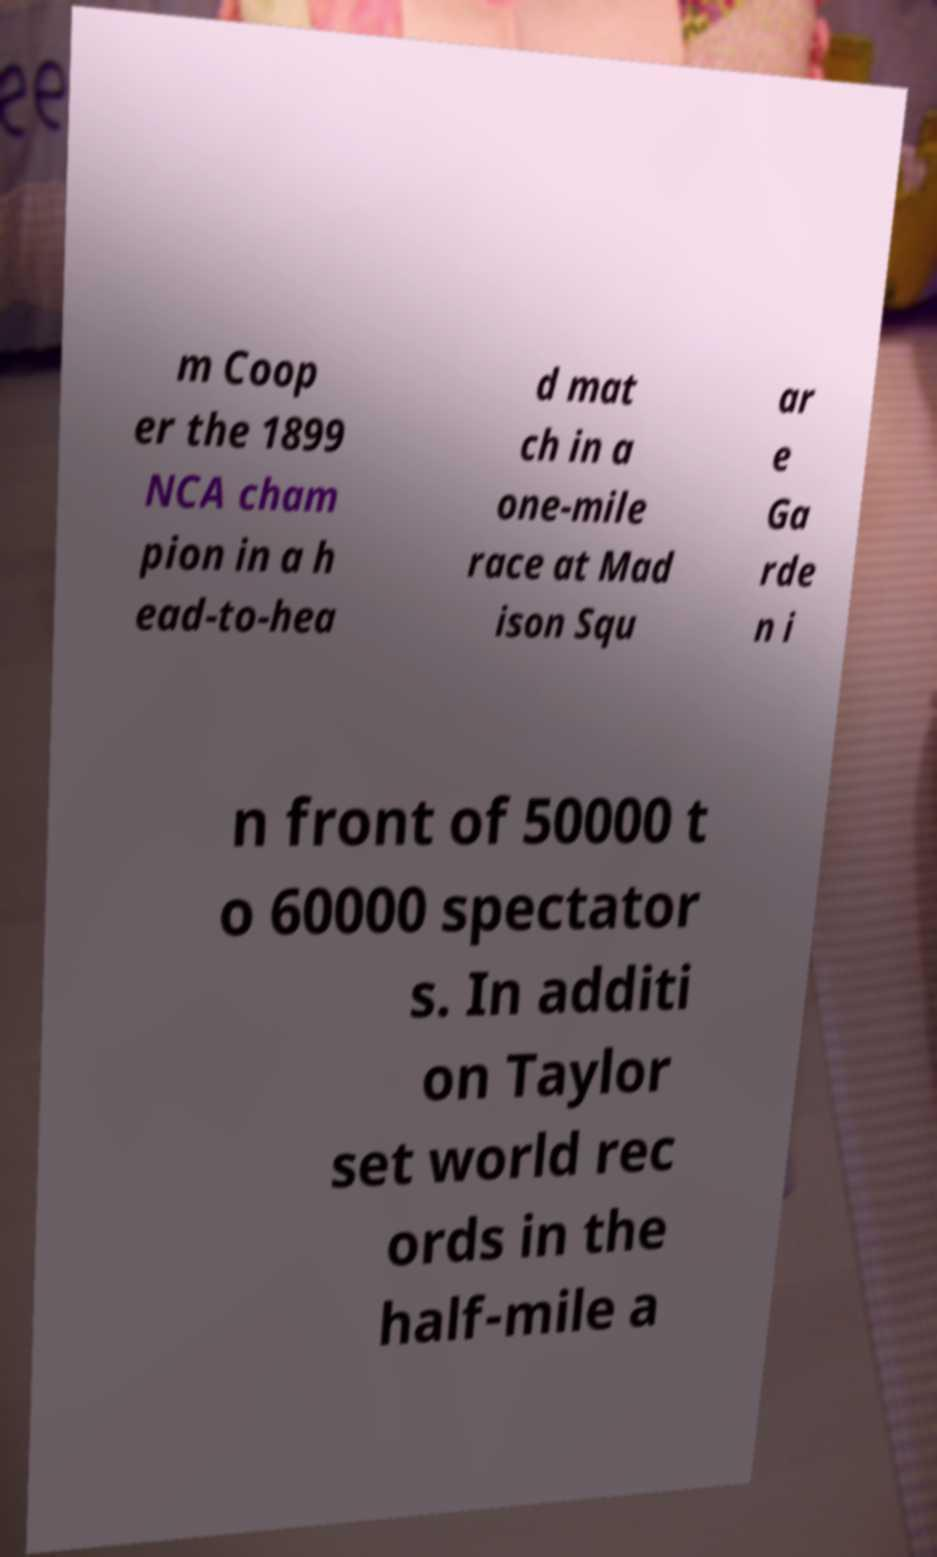What messages or text are displayed in this image? I need them in a readable, typed format. m Coop er the 1899 NCA cham pion in a h ead-to-hea d mat ch in a one-mile race at Mad ison Squ ar e Ga rde n i n front of 50000 t o 60000 spectator s. In additi on Taylor set world rec ords in the half-mile a 